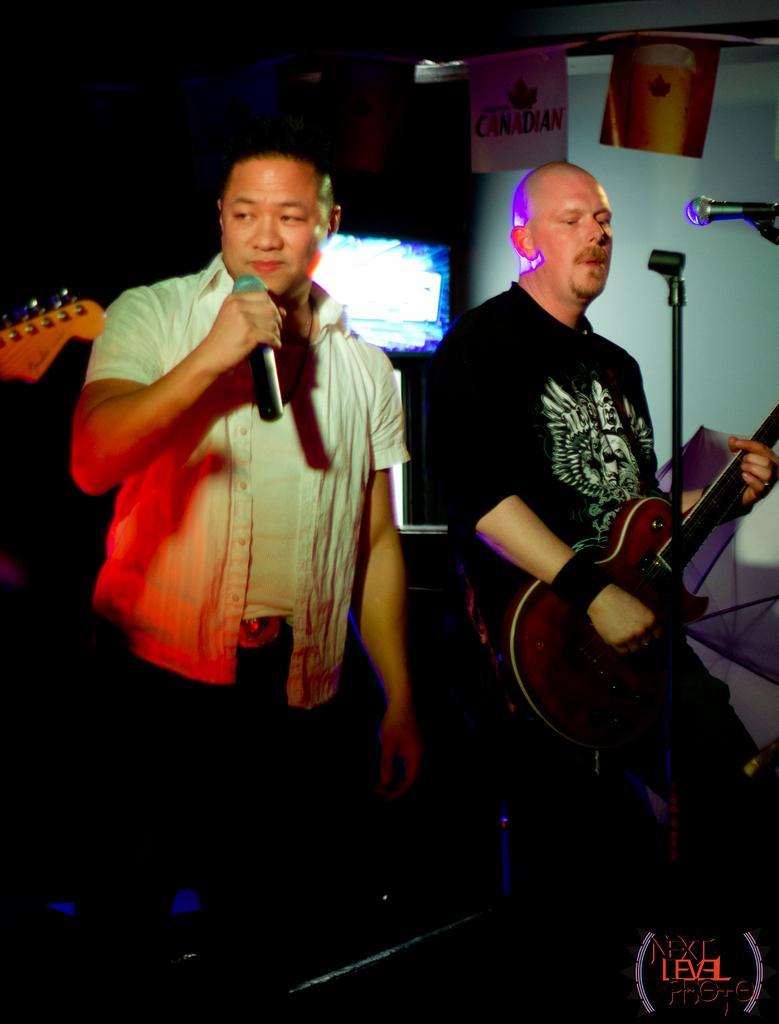Can you describe this image briefly? In this image we can see a person wearing white shirt is holding a mic in his hands and standing. The person wearing black t shirt is holding a guitar in his hands and playing it. 